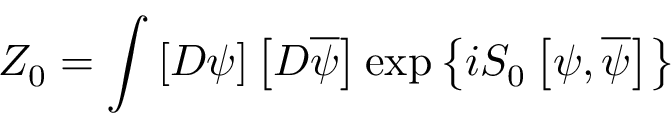<formula> <loc_0><loc_0><loc_500><loc_500>Z _ { 0 } = \int \left [ D \psi \right ] \left [ D \overline { \psi } \right ] \exp \left \{ i S _ { 0 } \left [ \psi , \overline { \psi } \right ] \right \}</formula> 